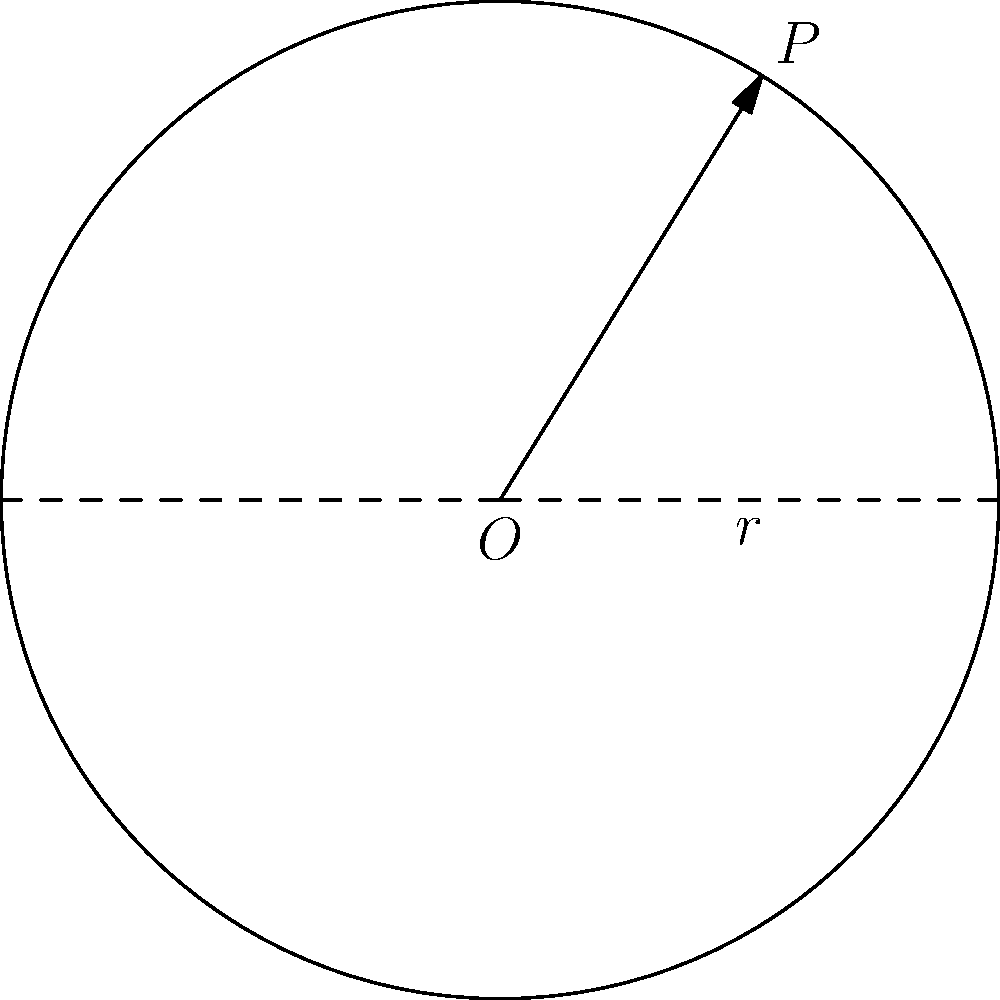In the town square, a circular fountain has been installed to enhance the aesthetic appeal and provide a gathering place for citizens. The radius of the fountain is 10 meters. As a concerned citizen interested in the proper maintenance of public spaces, you wish to calculate the circumference of the fountain to ensure adequate cleaning and upkeep. What is the circumference of the fountain to the nearest tenth of a meter? To calculate the circumference of the circular fountain, we'll follow these steps:

1. Recall the formula for the circumference of a circle:
   $C = 2\pi r$, where $C$ is the circumference, $\pi$ is pi, and $r$ is the radius.

2. We're given that the radius is 10 meters, so let's substitute this into our formula:
   $C = 2\pi (10)$

3. Simplify:
   $C = 20\pi$

4. Now, let's use $\pi \approx 3.14159$ for our calculation:
   $C \approx 20 \times 3.14159 = 62.8318$ meters

5. Rounding to the nearest tenth as requested:
   $C \approx 62.8$ meters

Thus, the circumference of the fountain is approximately 62.8 meters.
Answer: 62.8 meters 